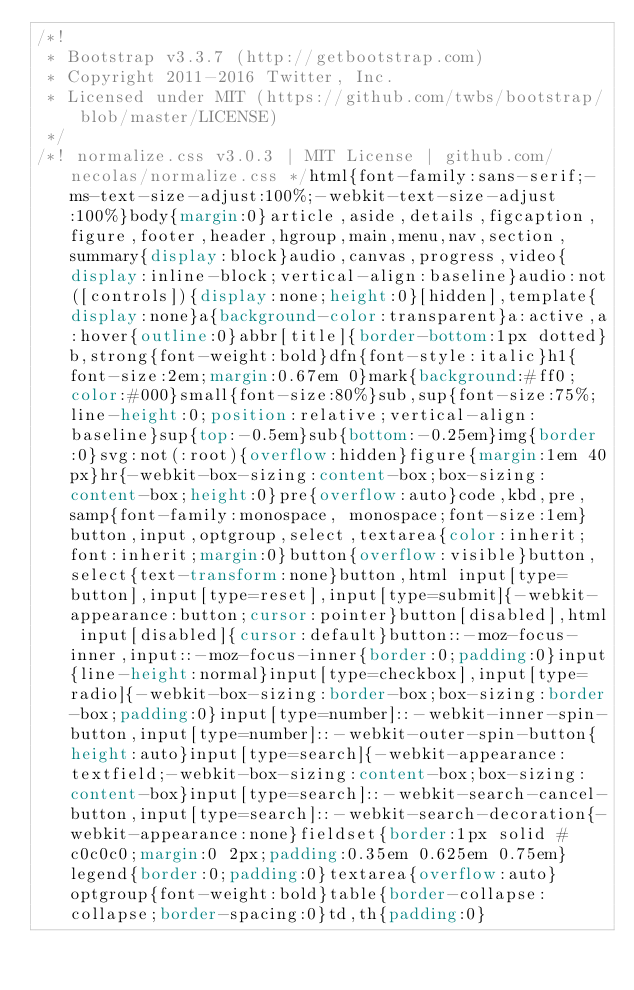<code> <loc_0><loc_0><loc_500><loc_500><_CSS_>/*!
 * Bootstrap v3.3.7 (http://getbootstrap.com)
 * Copyright 2011-2016 Twitter, Inc.
 * Licensed under MIT (https://github.com/twbs/bootstrap/blob/master/LICENSE)
 */
/*! normalize.css v3.0.3 | MIT License | github.com/necolas/normalize.css */html{font-family:sans-serif;-ms-text-size-adjust:100%;-webkit-text-size-adjust:100%}body{margin:0}article,aside,details,figcaption,figure,footer,header,hgroup,main,menu,nav,section,summary{display:block}audio,canvas,progress,video{display:inline-block;vertical-align:baseline}audio:not([controls]){display:none;height:0}[hidden],template{display:none}a{background-color:transparent}a:active,a:hover{outline:0}abbr[title]{border-bottom:1px dotted}b,strong{font-weight:bold}dfn{font-style:italic}h1{font-size:2em;margin:0.67em 0}mark{background:#ff0;color:#000}small{font-size:80%}sub,sup{font-size:75%;line-height:0;position:relative;vertical-align:baseline}sup{top:-0.5em}sub{bottom:-0.25em}img{border:0}svg:not(:root){overflow:hidden}figure{margin:1em 40px}hr{-webkit-box-sizing:content-box;box-sizing:content-box;height:0}pre{overflow:auto}code,kbd,pre,samp{font-family:monospace, monospace;font-size:1em}button,input,optgroup,select,textarea{color:inherit;font:inherit;margin:0}button{overflow:visible}button,select{text-transform:none}button,html input[type=button],input[type=reset],input[type=submit]{-webkit-appearance:button;cursor:pointer}button[disabled],html input[disabled]{cursor:default}button::-moz-focus-inner,input::-moz-focus-inner{border:0;padding:0}input{line-height:normal}input[type=checkbox],input[type=radio]{-webkit-box-sizing:border-box;box-sizing:border-box;padding:0}input[type=number]::-webkit-inner-spin-button,input[type=number]::-webkit-outer-spin-button{height:auto}input[type=search]{-webkit-appearance:textfield;-webkit-box-sizing:content-box;box-sizing:content-box}input[type=search]::-webkit-search-cancel-button,input[type=search]::-webkit-search-decoration{-webkit-appearance:none}fieldset{border:1px solid #c0c0c0;margin:0 2px;padding:0.35em 0.625em 0.75em}legend{border:0;padding:0}textarea{overflow:auto}optgroup{font-weight:bold}table{border-collapse:collapse;border-spacing:0}td,th{padding:0}</code> 